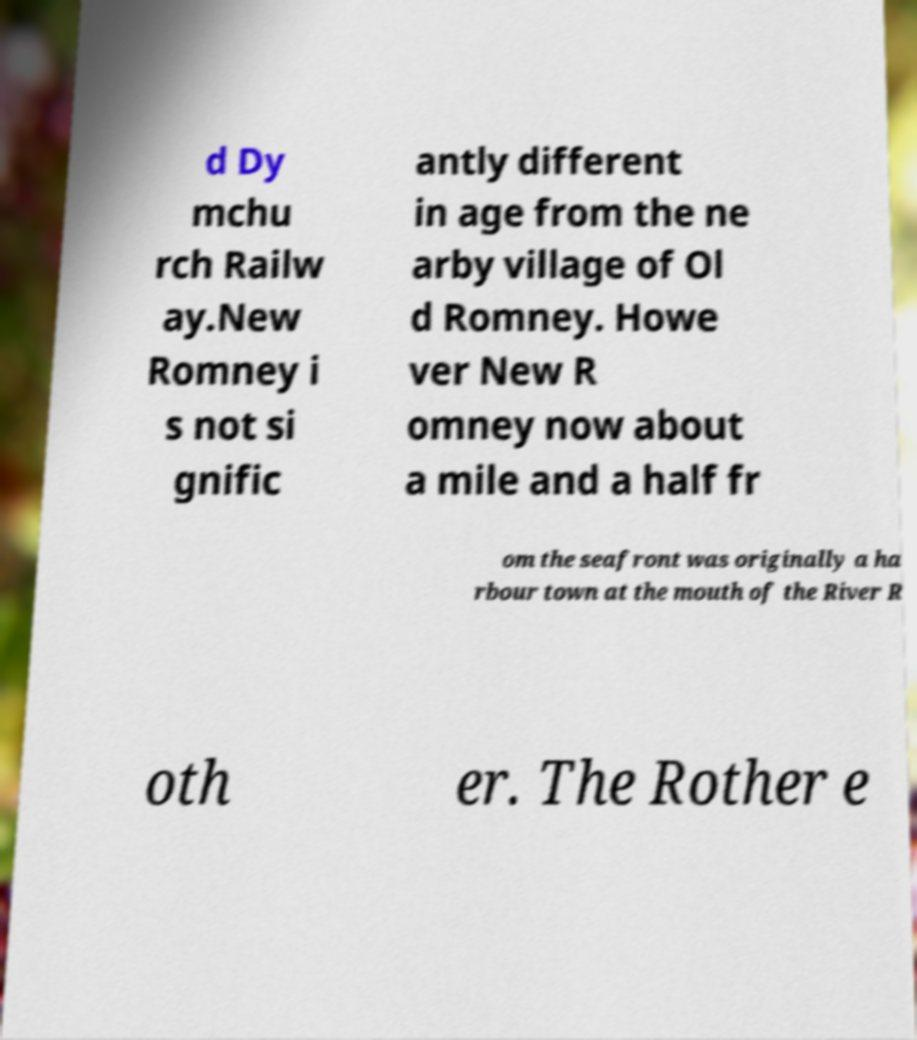I need the written content from this picture converted into text. Can you do that? d Dy mchu rch Railw ay.New Romney i s not si gnific antly different in age from the ne arby village of Ol d Romney. Howe ver New R omney now about a mile and a half fr om the seafront was originally a ha rbour town at the mouth of the River R oth er. The Rother e 